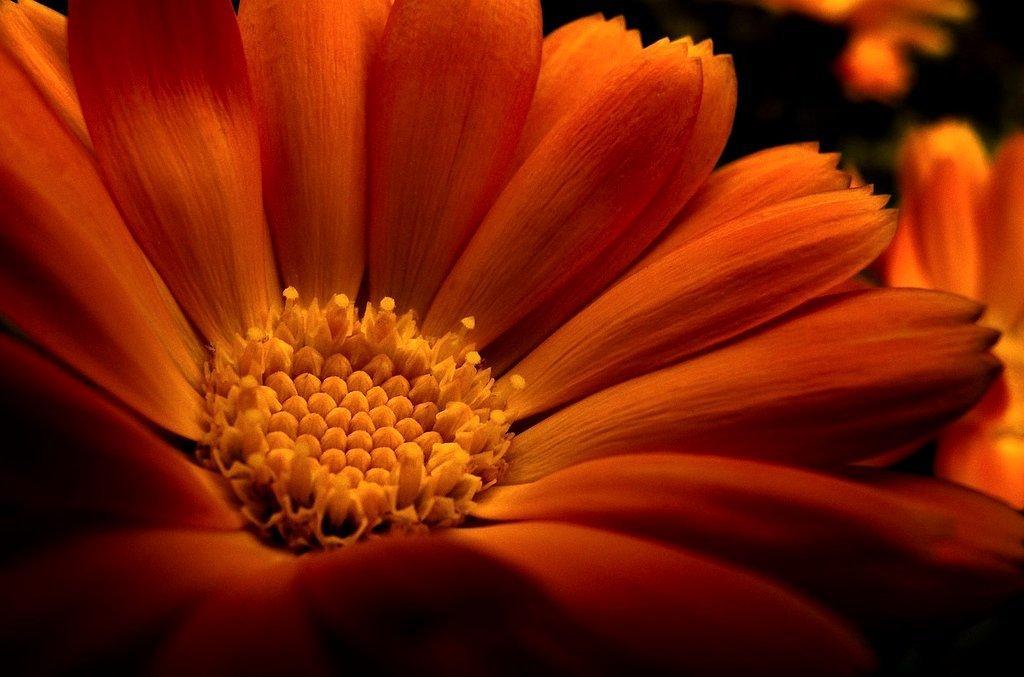Can you describe this image briefly? In the picture we can see a flower with petals and beside it also we can see some flowers. 